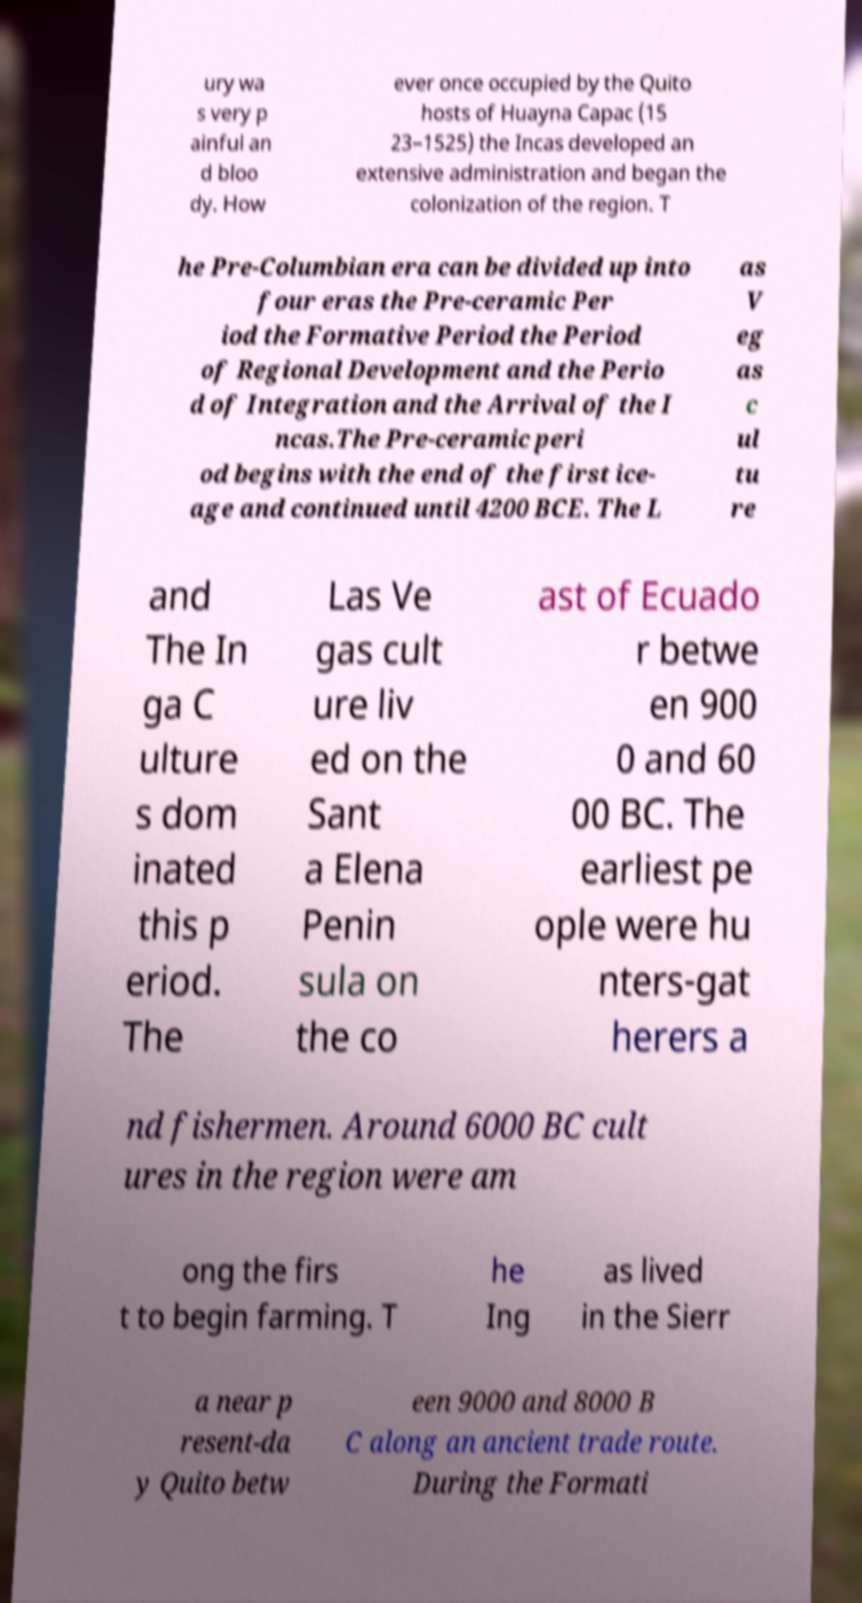Please read and relay the text visible in this image. What does it say? ury wa s very p ainful an d bloo dy. How ever once occupied by the Quito hosts of Huayna Capac (15 23–1525) the Incas developed an extensive administration and began the colonization of the region. T he Pre-Columbian era can be divided up into four eras the Pre-ceramic Per iod the Formative Period the Period of Regional Development and the Perio d of Integration and the Arrival of the I ncas.The Pre-ceramic peri od begins with the end of the first ice- age and continued until 4200 BCE. The L as V eg as c ul tu re and The In ga C ulture s dom inated this p eriod. The Las Ve gas cult ure liv ed on the Sant a Elena Penin sula on the co ast of Ecuado r betwe en 900 0 and 60 00 BC. The earliest pe ople were hu nters-gat herers a nd fishermen. Around 6000 BC cult ures in the region were am ong the firs t to begin farming. T he Ing as lived in the Sierr a near p resent-da y Quito betw een 9000 and 8000 B C along an ancient trade route. During the Formati 